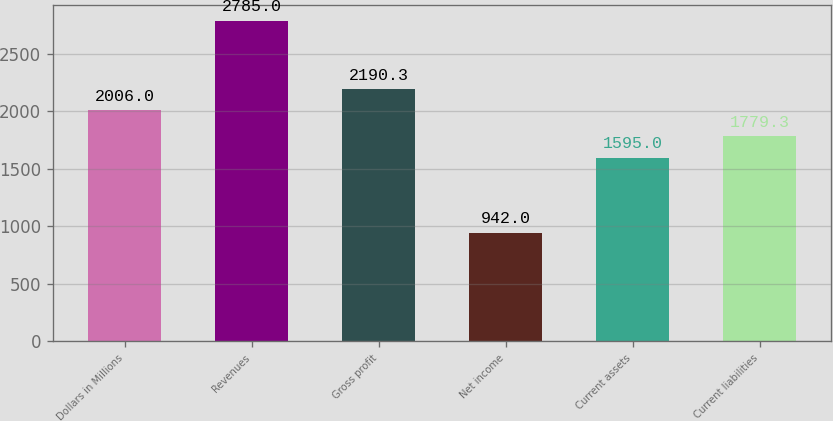Convert chart. <chart><loc_0><loc_0><loc_500><loc_500><bar_chart><fcel>Dollars in Millions<fcel>Revenues<fcel>Gross profit<fcel>Net income<fcel>Current assets<fcel>Current liabilities<nl><fcel>2006<fcel>2785<fcel>2190.3<fcel>942<fcel>1595<fcel>1779.3<nl></chart> 